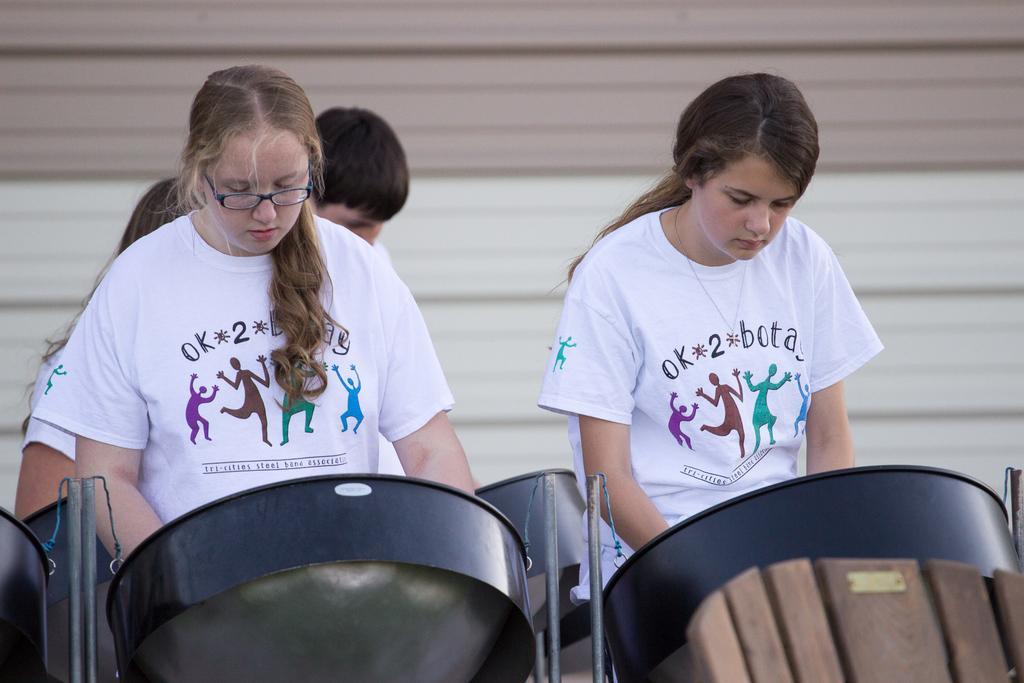In one or two sentences, can you explain what this image depicts? This picture seems to be clicked outside. In the foreground we can see the black color objects, metal rods and we can see the group of persons wearing white color t-shirts and standing on the ground. In the background there is an object seems to be a shutter. 